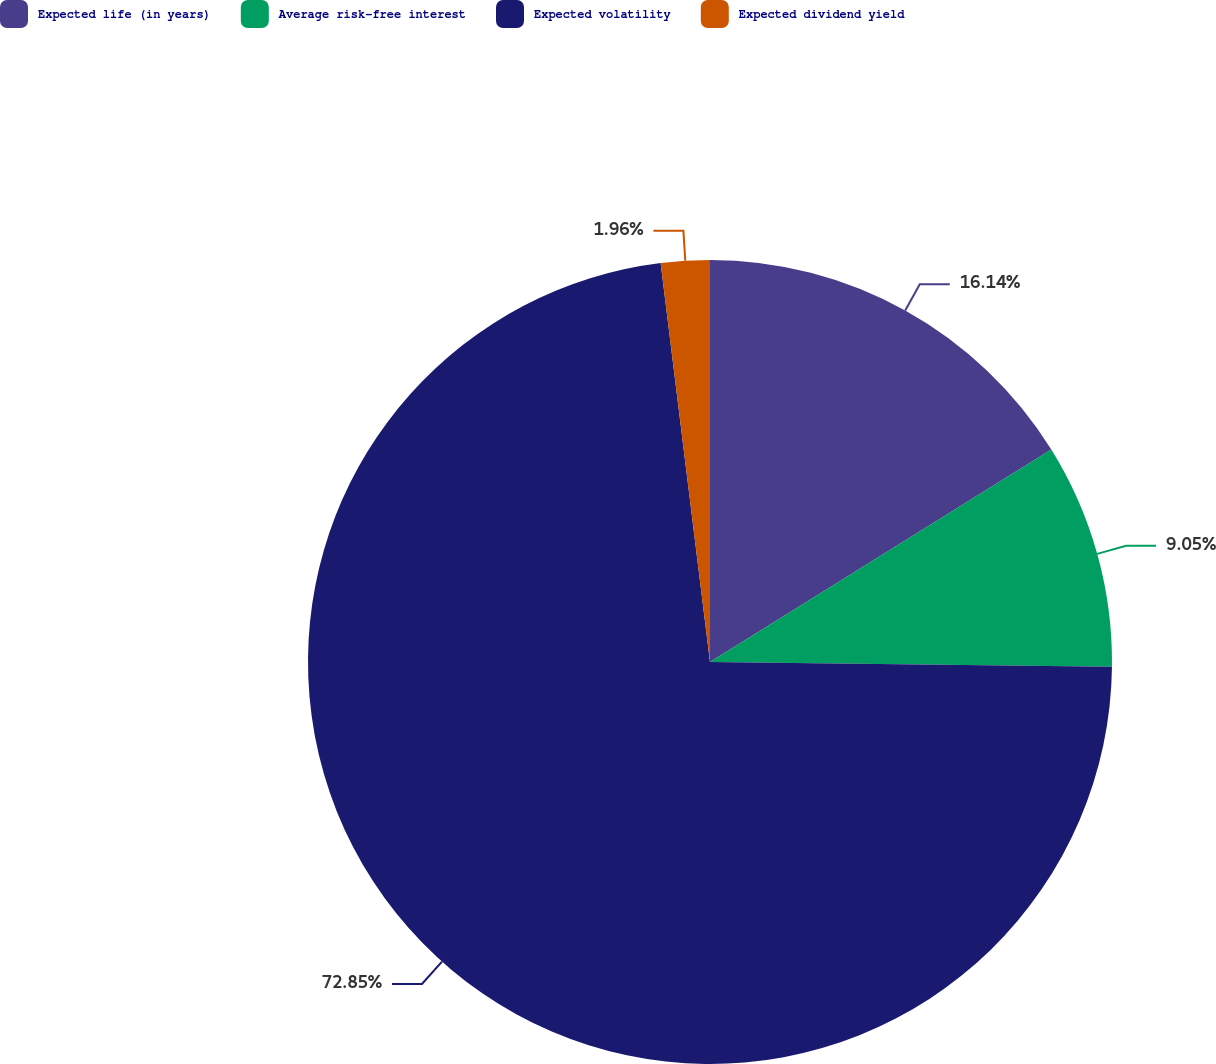Convert chart to OTSL. <chart><loc_0><loc_0><loc_500><loc_500><pie_chart><fcel>Expected life (in years)<fcel>Average risk-free interest<fcel>Expected volatility<fcel>Expected dividend yield<nl><fcel>16.14%<fcel>9.05%<fcel>72.85%<fcel>1.96%<nl></chart> 